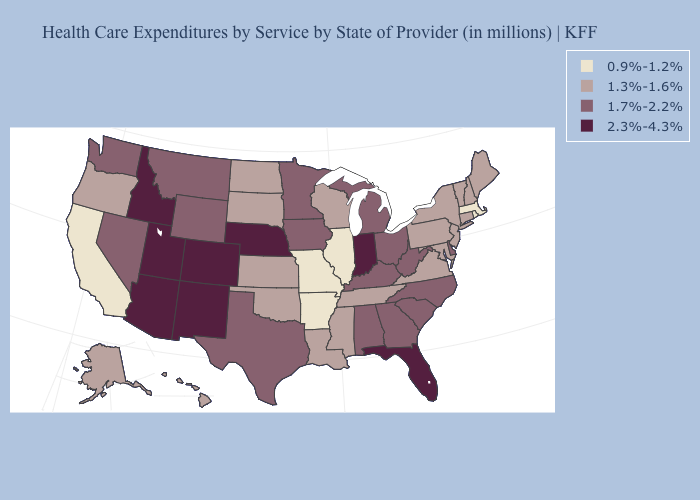Does Utah have a higher value than Nebraska?
Give a very brief answer. No. What is the value of Oklahoma?
Answer briefly. 1.3%-1.6%. Among the states that border Wisconsin , which have the highest value?
Be succinct. Iowa, Michigan, Minnesota. Does Missouri have the lowest value in the MidWest?
Quick response, please. Yes. What is the highest value in the Northeast ?
Be succinct. 1.3%-1.6%. Is the legend a continuous bar?
Keep it brief. No. Does Alaska have the same value as New Hampshire?
Write a very short answer. Yes. Does Montana have a lower value than Nebraska?
Write a very short answer. Yes. Does Colorado have the highest value in the USA?
Write a very short answer. Yes. What is the lowest value in the West?
Write a very short answer. 0.9%-1.2%. Does Utah have the highest value in the USA?
Concise answer only. Yes. What is the value of New Hampshire?
Be succinct. 1.3%-1.6%. Name the states that have a value in the range 1.7%-2.2%?
Concise answer only. Alabama, Delaware, Georgia, Iowa, Kentucky, Michigan, Minnesota, Montana, Nevada, North Carolina, Ohio, South Carolina, Texas, Washington, West Virginia, Wyoming. Name the states that have a value in the range 2.3%-4.3%?
Give a very brief answer. Arizona, Colorado, Florida, Idaho, Indiana, Nebraska, New Mexico, Utah. What is the lowest value in states that border Colorado?
Concise answer only. 1.3%-1.6%. 